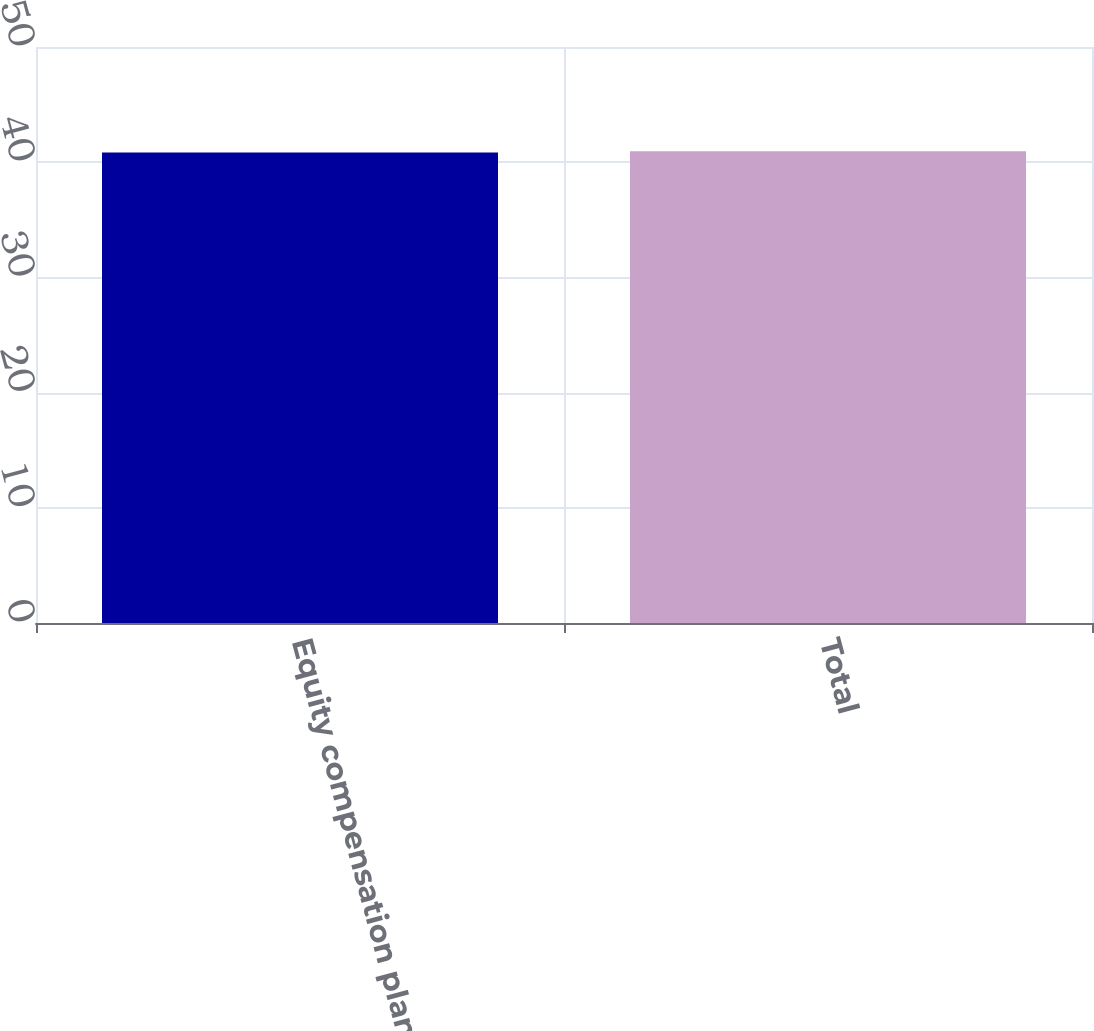Convert chart. <chart><loc_0><loc_0><loc_500><loc_500><bar_chart><fcel>Equity compensation plans<fcel>Total<nl><fcel>40.85<fcel>40.95<nl></chart> 